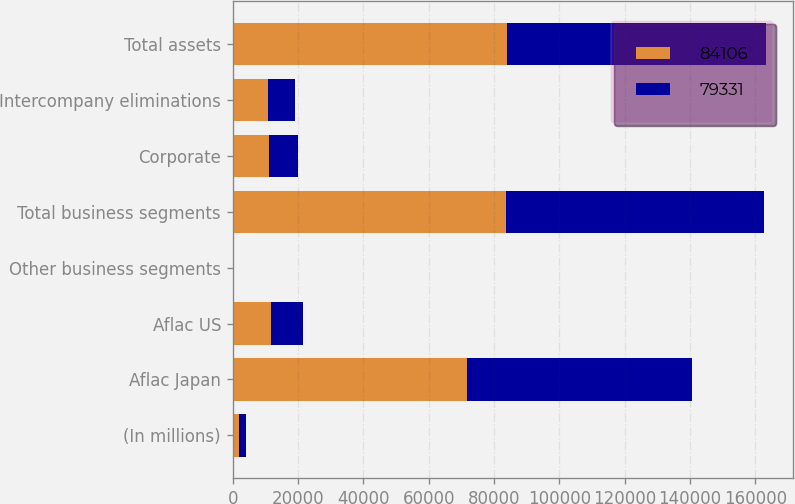Convert chart to OTSL. <chart><loc_0><loc_0><loc_500><loc_500><stacked_bar_chart><ecel><fcel>(In millions)<fcel>Aflac Japan<fcel>Aflac US<fcel>Other business segments<fcel>Total business segments<fcel>Corporate<fcel>Intercompany eliminations<fcel>Total assets<nl><fcel>84106<fcel>2009<fcel>71639<fcel>11779<fcel>142<fcel>83560<fcel>11261<fcel>10715<fcel>84106<nl><fcel>79331<fcel>2008<fcel>69141<fcel>9679<fcel>166<fcel>78986<fcel>8716<fcel>8371<fcel>79331<nl></chart> 